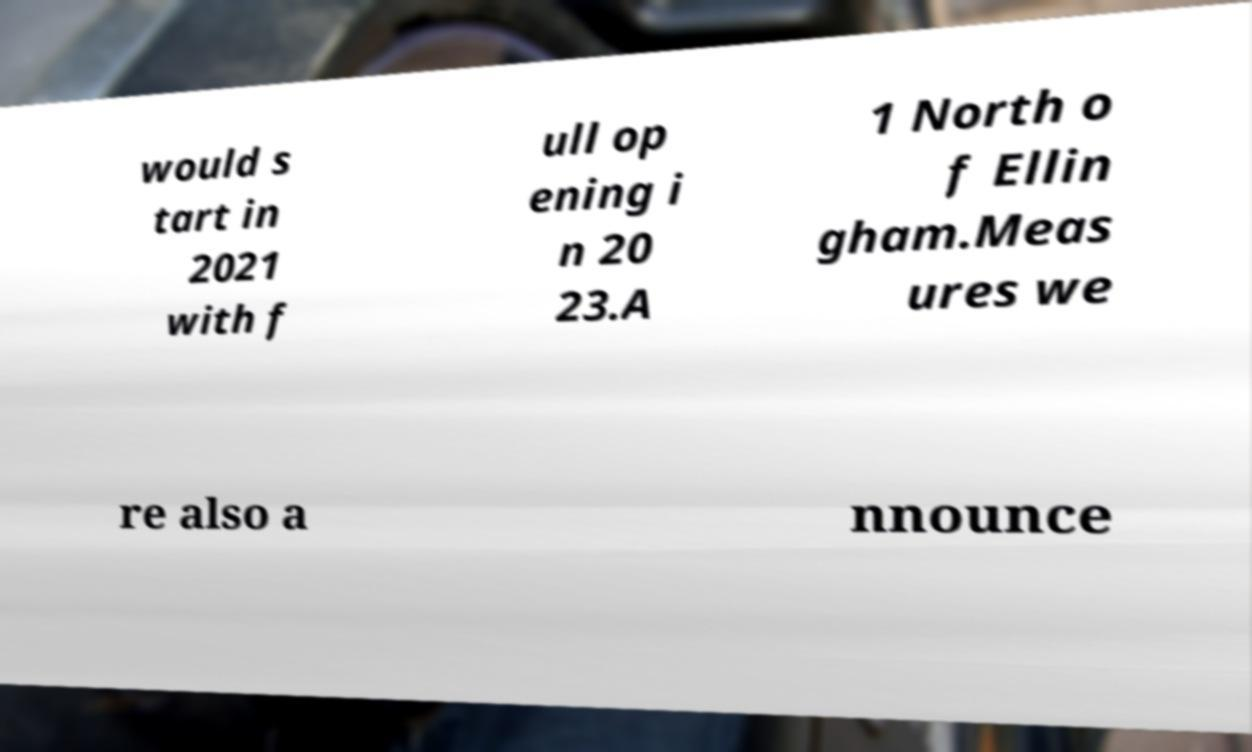What messages or text are displayed in this image? I need them in a readable, typed format. would s tart in 2021 with f ull op ening i n 20 23.A 1 North o f Ellin gham.Meas ures we re also a nnounce 